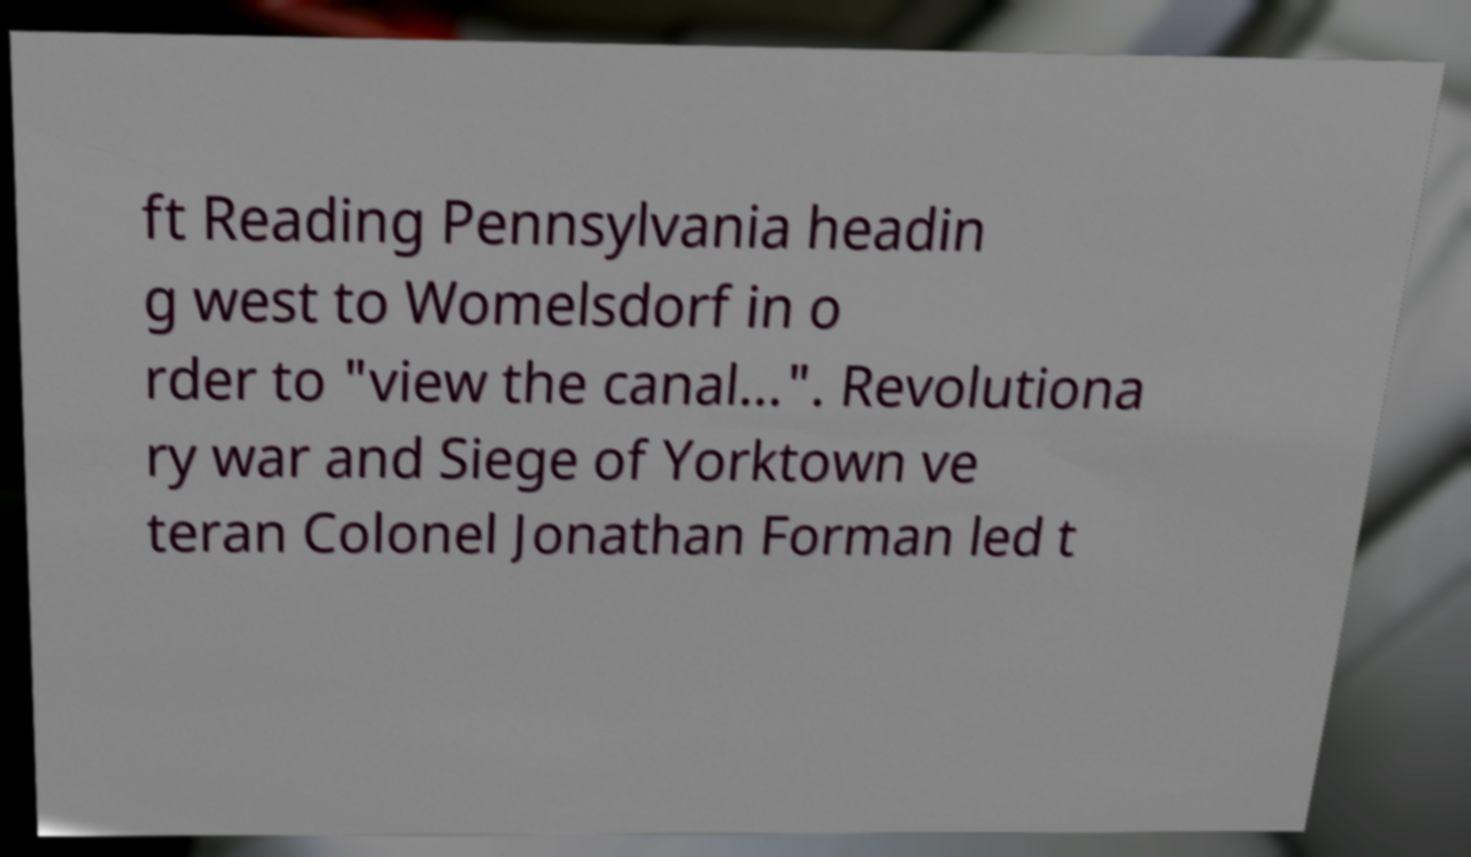What messages or text are displayed in this image? I need them in a readable, typed format. ft Reading Pennsylvania headin g west to Womelsdorf in o rder to "view the canal...". Revolutiona ry war and Siege of Yorktown ve teran Colonel Jonathan Forman led t 